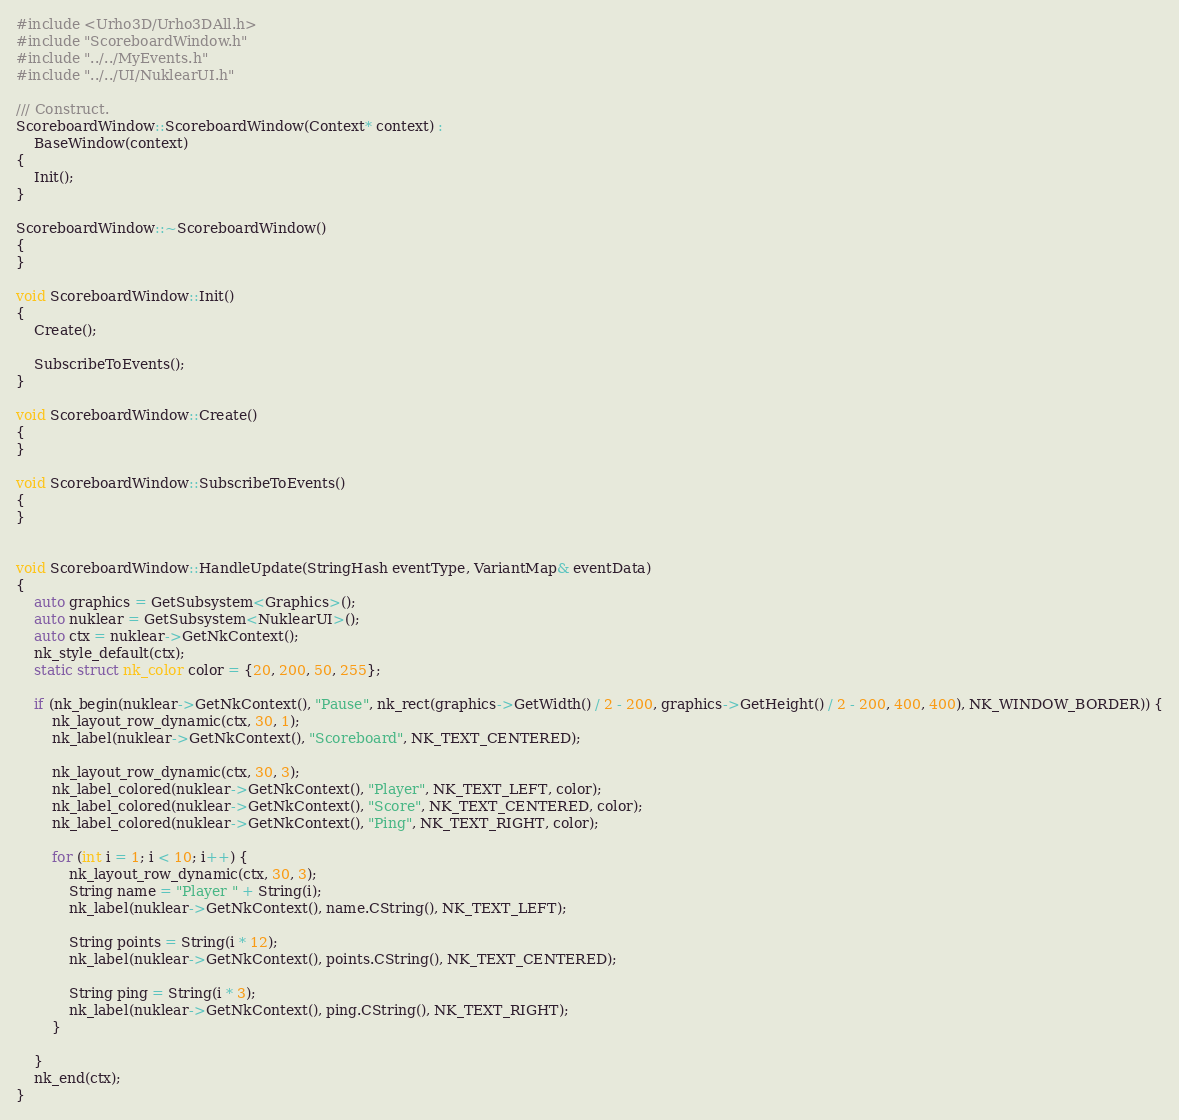Convert code to text. <code><loc_0><loc_0><loc_500><loc_500><_C++_>#include <Urho3D/Urho3DAll.h>
#include "ScoreboardWindow.h"
#include "../../MyEvents.h"
#include "../../UI/NuklearUI.h"

/// Construct.
ScoreboardWindow::ScoreboardWindow(Context* context) :
    BaseWindow(context)
{
    Init();
}

ScoreboardWindow::~ScoreboardWindow()
{
}

void ScoreboardWindow::Init()
{
    Create();

    SubscribeToEvents();
}

void ScoreboardWindow::Create()
{
}

void ScoreboardWindow::SubscribeToEvents()
{
}


void ScoreboardWindow::HandleUpdate(StringHash eventType, VariantMap& eventData)
{
    auto graphics = GetSubsystem<Graphics>();
    auto nuklear = GetSubsystem<NuklearUI>();
    auto ctx = nuklear->GetNkContext();
    nk_style_default(ctx);
    static struct nk_color color = {20, 200, 50, 255};

    if (nk_begin(nuklear->GetNkContext(), "Pause", nk_rect(graphics->GetWidth() / 2 - 200, graphics->GetHeight() / 2 - 200, 400, 400), NK_WINDOW_BORDER)) {
        nk_layout_row_dynamic(ctx, 30, 1);
        nk_label(nuklear->GetNkContext(), "Scoreboard", NK_TEXT_CENTERED);

        nk_layout_row_dynamic(ctx, 30, 3);
        nk_label_colored(nuklear->GetNkContext(), "Player", NK_TEXT_LEFT, color);
        nk_label_colored(nuklear->GetNkContext(), "Score", NK_TEXT_CENTERED, color);
        nk_label_colored(nuklear->GetNkContext(), "Ping", NK_TEXT_RIGHT, color);
        
        for (int i = 1; i < 10; i++) {
            nk_layout_row_dynamic(ctx, 30, 3);
            String name = "Player " + String(i);
            nk_label(nuklear->GetNkContext(), name.CString(), NK_TEXT_LEFT);

            String points = String(i * 12);
            nk_label(nuklear->GetNkContext(), points.CString(), NK_TEXT_CENTERED);

            String ping = String(i * 3);
            nk_label(nuklear->GetNkContext(), ping.CString(), NK_TEXT_RIGHT);
        }

    }
    nk_end(ctx);
}</code> 